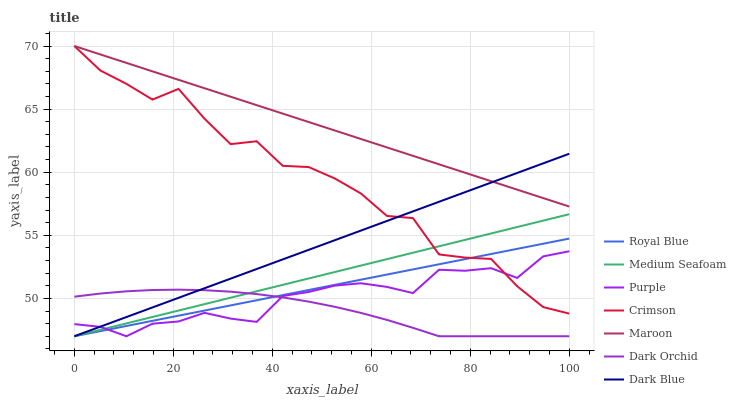Does Dark Orchid have the minimum area under the curve?
Answer yes or no. Yes. Does Maroon have the maximum area under the curve?
Answer yes or no. Yes. Does Purple have the minimum area under the curve?
Answer yes or no. No. Does Purple have the maximum area under the curve?
Answer yes or no. No. Is Dark Blue the smoothest?
Answer yes or no. Yes. Is Crimson the roughest?
Answer yes or no. Yes. Is Purple the smoothest?
Answer yes or no. No. Is Purple the roughest?
Answer yes or no. No. Does Dark Blue have the lowest value?
Answer yes or no. Yes. Does Maroon have the lowest value?
Answer yes or no. No. Does Crimson have the highest value?
Answer yes or no. Yes. Does Purple have the highest value?
Answer yes or no. No. Is Royal Blue less than Maroon?
Answer yes or no. Yes. Is Maroon greater than Purple?
Answer yes or no. Yes. Does Medium Seafoam intersect Crimson?
Answer yes or no. Yes. Is Medium Seafoam less than Crimson?
Answer yes or no. No. Is Medium Seafoam greater than Crimson?
Answer yes or no. No. Does Royal Blue intersect Maroon?
Answer yes or no. No. 